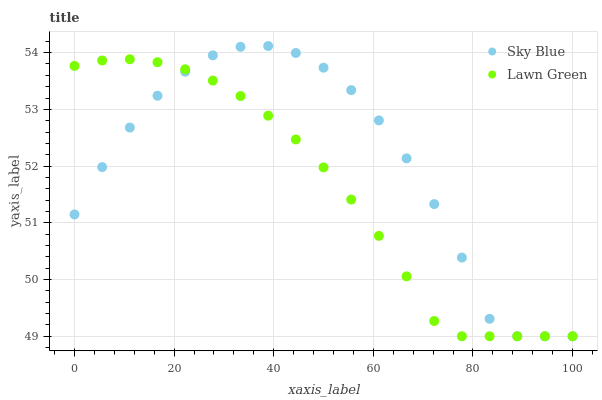Does Lawn Green have the minimum area under the curve?
Answer yes or no. Yes. Does Sky Blue have the maximum area under the curve?
Answer yes or no. Yes. Does Lawn Green have the maximum area under the curve?
Answer yes or no. No. Is Lawn Green the smoothest?
Answer yes or no. Yes. Is Sky Blue the roughest?
Answer yes or no. Yes. Is Lawn Green the roughest?
Answer yes or no. No. Does Sky Blue have the lowest value?
Answer yes or no. Yes. Does Sky Blue have the highest value?
Answer yes or no. Yes. Does Lawn Green have the highest value?
Answer yes or no. No. Does Sky Blue intersect Lawn Green?
Answer yes or no. Yes. Is Sky Blue less than Lawn Green?
Answer yes or no. No. Is Sky Blue greater than Lawn Green?
Answer yes or no. No. 